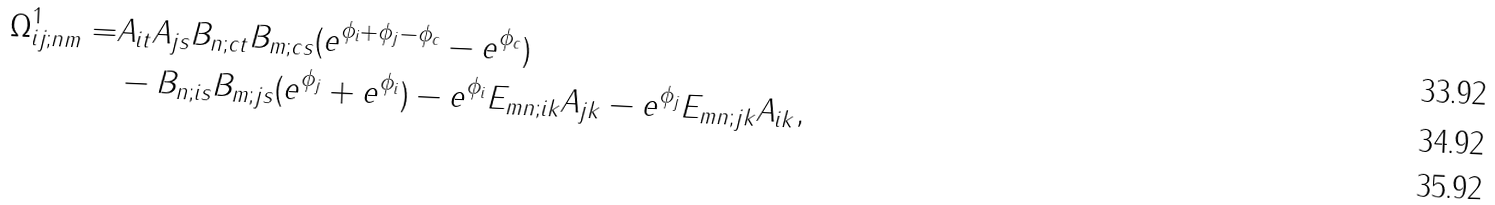Convert formula to latex. <formula><loc_0><loc_0><loc_500><loc_500>\Omega ^ { 1 } _ { i j ; n m } = & A _ { i t } A _ { j s } B _ { n ; c t } B _ { m ; c s } ( e ^ { \phi _ { i } + \phi _ { j } - \phi _ { c } } - e ^ { \phi _ { c } } ) \\ & - B _ { n ; i s } B _ { m ; j s } ( e ^ { \phi _ { j } } + e ^ { \phi _ { i } } ) - e ^ { \phi _ { i } } E _ { m n ; i k } A _ { j k } - e ^ { \phi _ { j } } E _ { m n ; j k } A _ { i k } , \\</formula> 